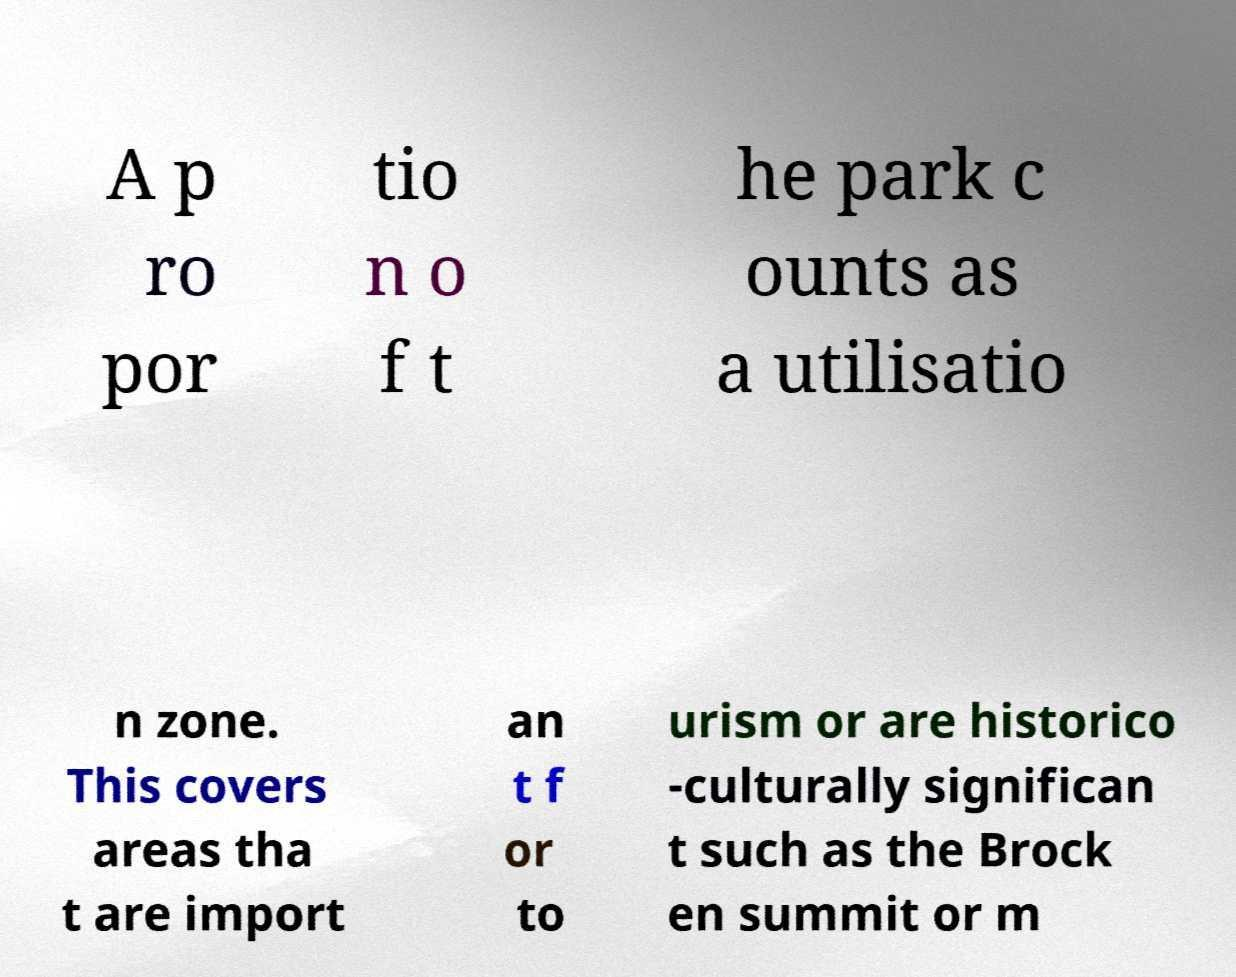Please read and relay the text visible in this image. What does it say? A p ro por tio n o f t he park c ounts as a utilisatio n zone. This covers areas tha t are import an t f or to urism or are historico -culturally significan t such as the Brock en summit or m 